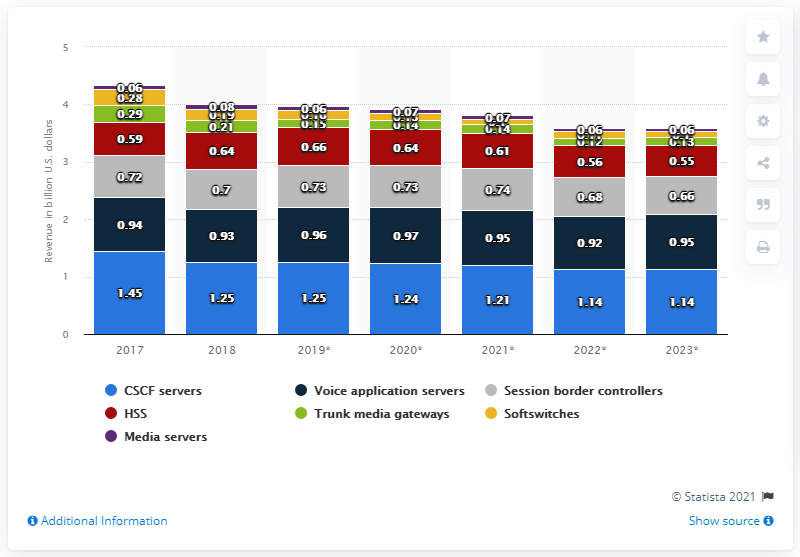Highlight a few significant elements in this photo. In 2018, the Call Session Control Function (CSCF) servers generated a revenue of 1.24... 